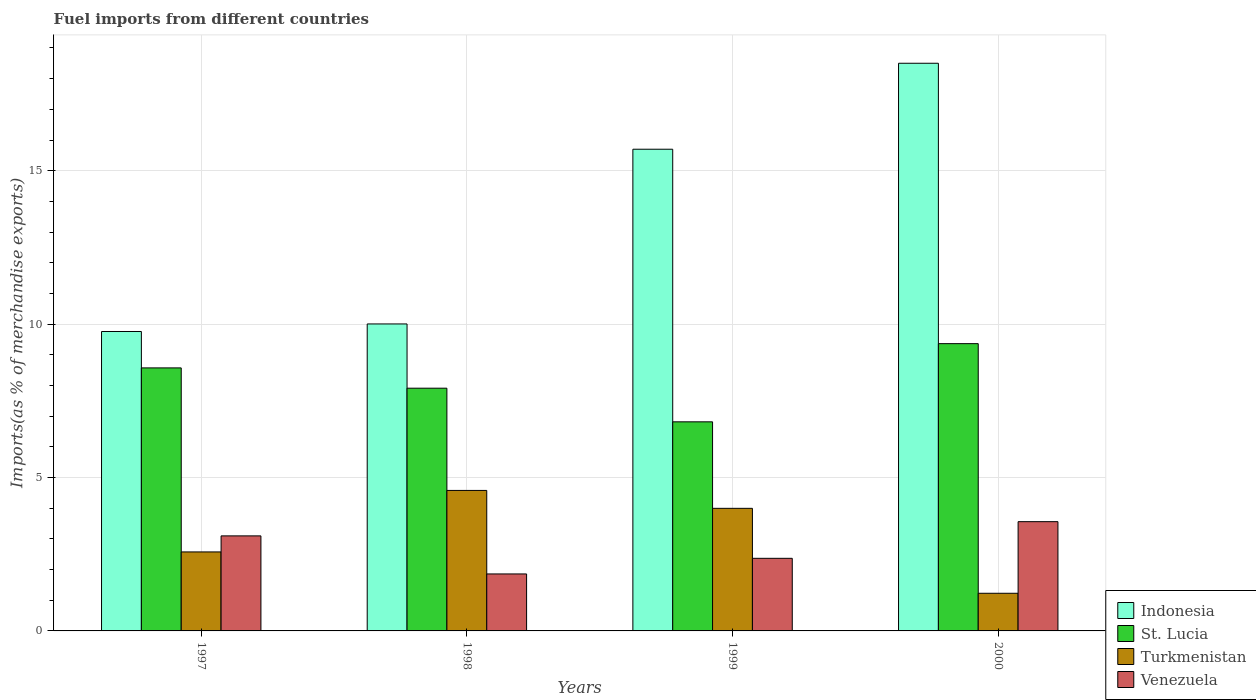How many different coloured bars are there?
Your response must be concise. 4. How many groups of bars are there?
Give a very brief answer. 4. Are the number of bars per tick equal to the number of legend labels?
Your response must be concise. Yes. How many bars are there on the 2nd tick from the left?
Provide a short and direct response. 4. What is the label of the 2nd group of bars from the left?
Offer a terse response. 1998. In how many cases, is the number of bars for a given year not equal to the number of legend labels?
Your answer should be very brief. 0. What is the percentage of imports to different countries in Turkmenistan in 2000?
Give a very brief answer. 1.23. Across all years, what is the maximum percentage of imports to different countries in St. Lucia?
Give a very brief answer. 9.36. Across all years, what is the minimum percentage of imports to different countries in Venezuela?
Make the answer very short. 1.86. In which year was the percentage of imports to different countries in St. Lucia minimum?
Give a very brief answer. 1999. What is the total percentage of imports to different countries in Indonesia in the graph?
Ensure brevity in your answer.  53.97. What is the difference between the percentage of imports to different countries in St. Lucia in 1998 and that in 1999?
Make the answer very short. 1.1. What is the difference between the percentage of imports to different countries in St. Lucia in 1998 and the percentage of imports to different countries in Venezuela in 1999?
Ensure brevity in your answer.  5.54. What is the average percentage of imports to different countries in St. Lucia per year?
Your answer should be very brief. 8.17. In the year 1998, what is the difference between the percentage of imports to different countries in Turkmenistan and percentage of imports to different countries in Venezuela?
Make the answer very short. 2.72. In how many years, is the percentage of imports to different countries in Indonesia greater than 8 %?
Make the answer very short. 4. What is the ratio of the percentage of imports to different countries in Venezuela in 1997 to that in 2000?
Make the answer very short. 0.87. What is the difference between the highest and the second highest percentage of imports to different countries in Indonesia?
Ensure brevity in your answer.  2.8. What is the difference between the highest and the lowest percentage of imports to different countries in Venezuela?
Make the answer very short. 1.7. In how many years, is the percentage of imports to different countries in Turkmenistan greater than the average percentage of imports to different countries in Turkmenistan taken over all years?
Ensure brevity in your answer.  2. Is it the case that in every year, the sum of the percentage of imports to different countries in St. Lucia and percentage of imports to different countries in Indonesia is greater than the sum of percentage of imports to different countries in Venezuela and percentage of imports to different countries in Turkmenistan?
Your response must be concise. Yes. What does the 4th bar from the left in 1998 represents?
Offer a terse response. Venezuela. What does the 2nd bar from the right in 2000 represents?
Give a very brief answer. Turkmenistan. Is it the case that in every year, the sum of the percentage of imports to different countries in Turkmenistan and percentage of imports to different countries in Indonesia is greater than the percentage of imports to different countries in St. Lucia?
Offer a terse response. Yes. How many bars are there?
Ensure brevity in your answer.  16. Are all the bars in the graph horizontal?
Provide a succinct answer. No. How many years are there in the graph?
Provide a short and direct response. 4. Does the graph contain any zero values?
Keep it short and to the point. No. Does the graph contain grids?
Your answer should be compact. Yes. Where does the legend appear in the graph?
Ensure brevity in your answer.  Bottom right. What is the title of the graph?
Offer a very short reply. Fuel imports from different countries. Does "Cayman Islands" appear as one of the legend labels in the graph?
Make the answer very short. No. What is the label or title of the Y-axis?
Provide a short and direct response. Imports(as % of merchandise exports). What is the Imports(as % of merchandise exports) of Indonesia in 1997?
Provide a short and direct response. 9.76. What is the Imports(as % of merchandise exports) of St. Lucia in 1997?
Your response must be concise. 8.57. What is the Imports(as % of merchandise exports) in Turkmenistan in 1997?
Provide a succinct answer. 2.57. What is the Imports(as % of merchandise exports) of Venezuela in 1997?
Your answer should be compact. 3.1. What is the Imports(as % of merchandise exports) in Indonesia in 1998?
Make the answer very short. 10. What is the Imports(as % of merchandise exports) of St. Lucia in 1998?
Offer a very short reply. 7.91. What is the Imports(as % of merchandise exports) in Turkmenistan in 1998?
Offer a terse response. 4.58. What is the Imports(as % of merchandise exports) in Venezuela in 1998?
Provide a succinct answer. 1.86. What is the Imports(as % of merchandise exports) of Indonesia in 1999?
Your answer should be very brief. 15.7. What is the Imports(as % of merchandise exports) of St. Lucia in 1999?
Provide a succinct answer. 6.81. What is the Imports(as % of merchandise exports) of Turkmenistan in 1999?
Ensure brevity in your answer.  4. What is the Imports(as % of merchandise exports) in Venezuela in 1999?
Give a very brief answer. 2.37. What is the Imports(as % of merchandise exports) in Indonesia in 2000?
Provide a succinct answer. 18.5. What is the Imports(as % of merchandise exports) in St. Lucia in 2000?
Make the answer very short. 9.36. What is the Imports(as % of merchandise exports) of Turkmenistan in 2000?
Ensure brevity in your answer.  1.23. What is the Imports(as % of merchandise exports) in Venezuela in 2000?
Give a very brief answer. 3.56. Across all years, what is the maximum Imports(as % of merchandise exports) in Indonesia?
Give a very brief answer. 18.5. Across all years, what is the maximum Imports(as % of merchandise exports) of St. Lucia?
Provide a succinct answer. 9.36. Across all years, what is the maximum Imports(as % of merchandise exports) in Turkmenistan?
Your answer should be very brief. 4.58. Across all years, what is the maximum Imports(as % of merchandise exports) of Venezuela?
Offer a very short reply. 3.56. Across all years, what is the minimum Imports(as % of merchandise exports) in Indonesia?
Keep it short and to the point. 9.76. Across all years, what is the minimum Imports(as % of merchandise exports) of St. Lucia?
Offer a terse response. 6.81. Across all years, what is the minimum Imports(as % of merchandise exports) of Turkmenistan?
Provide a succinct answer. 1.23. Across all years, what is the minimum Imports(as % of merchandise exports) in Venezuela?
Offer a very short reply. 1.86. What is the total Imports(as % of merchandise exports) in Indonesia in the graph?
Keep it short and to the point. 53.97. What is the total Imports(as % of merchandise exports) in St. Lucia in the graph?
Make the answer very short. 32.66. What is the total Imports(as % of merchandise exports) in Turkmenistan in the graph?
Offer a terse response. 12.38. What is the total Imports(as % of merchandise exports) of Venezuela in the graph?
Ensure brevity in your answer.  10.88. What is the difference between the Imports(as % of merchandise exports) in Indonesia in 1997 and that in 1998?
Give a very brief answer. -0.25. What is the difference between the Imports(as % of merchandise exports) of St. Lucia in 1997 and that in 1998?
Your answer should be compact. 0.66. What is the difference between the Imports(as % of merchandise exports) of Turkmenistan in 1997 and that in 1998?
Your answer should be compact. -2. What is the difference between the Imports(as % of merchandise exports) of Venezuela in 1997 and that in 1998?
Offer a terse response. 1.24. What is the difference between the Imports(as % of merchandise exports) of Indonesia in 1997 and that in 1999?
Provide a short and direct response. -5.94. What is the difference between the Imports(as % of merchandise exports) in St. Lucia in 1997 and that in 1999?
Give a very brief answer. 1.76. What is the difference between the Imports(as % of merchandise exports) in Turkmenistan in 1997 and that in 1999?
Provide a short and direct response. -1.42. What is the difference between the Imports(as % of merchandise exports) of Venezuela in 1997 and that in 1999?
Offer a very short reply. 0.73. What is the difference between the Imports(as % of merchandise exports) of Indonesia in 1997 and that in 2000?
Provide a succinct answer. -8.74. What is the difference between the Imports(as % of merchandise exports) of St. Lucia in 1997 and that in 2000?
Your answer should be very brief. -0.79. What is the difference between the Imports(as % of merchandise exports) of Turkmenistan in 1997 and that in 2000?
Make the answer very short. 1.35. What is the difference between the Imports(as % of merchandise exports) of Venezuela in 1997 and that in 2000?
Give a very brief answer. -0.46. What is the difference between the Imports(as % of merchandise exports) of Indonesia in 1998 and that in 1999?
Offer a terse response. -5.69. What is the difference between the Imports(as % of merchandise exports) of St. Lucia in 1998 and that in 1999?
Offer a very short reply. 1.1. What is the difference between the Imports(as % of merchandise exports) in Turkmenistan in 1998 and that in 1999?
Provide a succinct answer. 0.58. What is the difference between the Imports(as % of merchandise exports) in Venezuela in 1998 and that in 1999?
Offer a very short reply. -0.51. What is the difference between the Imports(as % of merchandise exports) in Indonesia in 1998 and that in 2000?
Ensure brevity in your answer.  -8.5. What is the difference between the Imports(as % of merchandise exports) in St. Lucia in 1998 and that in 2000?
Ensure brevity in your answer.  -1.45. What is the difference between the Imports(as % of merchandise exports) in Turkmenistan in 1998 and that in 2000?
Make the answer very short. 3.35. What is the difference between the Imports(as % of merchandise exports) in Venezuela in 1998 and that in 2000?
Your answer should be compact. -1.7. What is the difference between the Imports(as % of merchandise exports) in Indonesia in 1999 and that in 2000?
Give a very brief answer. -2.8. What is the difference between the Imports(as % of merchandise exports) in St. Lucia in 1999 and that in 2000?
Make the answer very short. -2.55. What is the difference between the Imports(as % of merchandise exports) of Turkmenistan in 1999 and that in 2000?
Provide a succinct answer. 2.77. What is the difference between the Imports(as % of merchandise exports) of Venezuela in 1999 and that in 2000?
Your answer should be compact. -1.19. What is the difference between the Imports(as % of merchandise exports) of Indonesia in 1997 and the Imports(as % of merchandise exports) of St. Lucia in 1998?
Provide a succinct answer. 1.85. What is the difference between the Imports(as % of merchandise exports) in Indonesia in 1997 and the Imports(as % of merchandise exports) in Turkmenistan in 1998?
Make the answer very short. 5.18. What is the difference between the Imports(as % of merchandise exports) in Indonesia in 1997 and the Imports(as % of merchandise exports) in Venezuela in 1998?
Keep it short and to the point. 7.9. What is the difference between the Imports(as % of merchandise exports) in St. Lucia in 1997 and the Imports(as % of merchandise exports) in Turkmenistan in 1998?
Offer a very short reply. 3.99. What is the difference between the Imports(as % of merchandise exports) in St. Lucia in 1997 and the Imports(as % of merchandise exports) in Venezuela in 1998?
Keep it short and to the point. 6.72. What is the difference between the Imports(as % of merchandise exports) in Turkmenistan in 1997 and the Imports(as % of merchandise exports) in Venezuela in 1998?
Your answer should be compact. 0.72. What is the difference between the Imports(as % of merchandise exports) of Indonesia in 1997 and the Imports(as % of merchandise exports) of St. Lucia in 1999?
Offer a very short reply. 2.94. What is the difference between the Imports(as % of merchandise exports) of Indonesia in 1997 and the Imports(as % of merchandise exports) of Turkmenistan in 1999?
Keep it short and to the point. 5.76. What is the difference between the Imports(as % of merchandise exports) in Indonesia in 1997 and the Imports(as % of merchandise exports) in Venezuela in 1999?
Keep it short and to the point. 7.39. What is the difference between the Imports(as % of merchandise exports) of St. Lucia in 1997 and the Imports(as % of merchandise exports) of Turkmenistan in 1999?
Make the answer very short. 4.58. What is the difference between the Imports(as % of merchandise exports) in St. Lucia in 1997 and the Imports(as % of merchandise exports) in Venezuela in 1999?
Give a very brief answer. 6.21. What is the difference between the Imports(as % of merchandise exports) in Turkmenistan in 1997 and the Imports(as % of merchandise exports) in Venezuela in 1999?
Your answer should be very brief. 0.21. What is the difference between the Imports(as % of merchandise exports) of Indonesia in 1997 and the Imports(as % of merchandise exports) of St. Lucia in 2000?
Provide a succinct answer. 0.4. What is the difference between the Imports(as % of merchandise exports) in Indonesia in 1997 and the Imports(as % of merchandise exports) in Turkmenistan in 2000?
Your answer should be compact. 8.53. What is the difference between the Imports(as % of merchandise exports) in Indonesia in 1997 and the Imports(as % of merchandise exports) in Venezuela in 2000?
Your response must be concise. 6.2. What is the difference between the Imports(as % of merchandise exports) in St. Lucia in 1997 and the Imports(as % of merchandise exports) in Turkmenistan in 2000?
Provide a succinct answer. 7.35. What is the difference between the Imports(as % of merchandise exports) in St. Lucia in 1997 and the Imports(as % of merchandise exports) in Venezuela in 2000?
Make the answer very short. 5.01. What is the difference between the Imports(as % of merchandise exports) in Turkmenistan in 1997 and the Imports(as % of merchandise exports) in Venezuela in 2000?
Offer a very short reply. -0.99. What is the difference between the Imports(as % of merchandise exports) of Indonesia in 1998 and the Imports(as % of merchandise exports) of St. Lucia in 1999?
Your response must be concise. 3.19. What is the difference between the Imports(as % of merchandise exports) of Indonesia in 1998 and the Imports(as % of merchandise exports) of Turkmenistan in 1999?
Make the answer very short. 6.01. What is the difference between the Imports(as % of merchandise exports) in Indonesia in 1998 and the Imports(as % of merchandise exports) in Venezuela in 1999?
Ensure brevity in your answer.  7.64. What is the difference between the Imports(as % of merchandise exports) of St. Lucia in 1998 and the Imports(as % of merchandise exports) of Turkmenistan in 1999?
Offer a very short reply. 3.92. What is the difference between the Imports(as % of merchandise exports) of St. Lucia in 1998 and the Imports(as % of merchandise exports) of Venezuela in 1999?
Offer a very short reply. 5.54. What is the difference between the Imports(as % of merchandise exports) in Turkmenistan in 1998 and the Imports(as % of merchandise exports) in Venezuela in 1999?
Provide a short and direct response. 2.21. What is the difference between the Imports(as % of merchandise exports) in Indonesia in 1998 and the Imports(as % of merchandise exports) in St. Lucia in 2000?
Give a very brief answer. 0.64. What is the difference between the Imports(as % of merchandise exports) of Indonesia in 1998 and the Imports(as % of merchandise exports) of Turkmenistan in 2000?
Your answer should be compact. 8.78. What is the difference between the Imports(as % of merchandise exports) in Indonesia in 1998 and the Imports(as % of merchandise exports) in Venezuela in 2000?
Provide a succinct answer. 6.44. What is the difference between the Imports(as % of merchandise exports) in St. Lucia in 1998 and the Imports(as % of merchandise exports) in Turkmenistan in 2000?
Provide a succinct answer. 6.68. What is the difference between the Imports(as % of merchandise exports) in St. Lucia in 1998 and the Imports(as % of merchandise exports) in Venezuela in 2000?
Give a very brief answer. 4.35. What is the difference between the Imports(as % of merchandise exports) in Turkmenistan in 1998 and the Imports(as % of merchandise exports) in Venezuela in 2000?
Your answer should be very brief. 1.02. What is the difference between the Imports(as % of merchandise exports) of Indonesia in 1999 and the Imports(as % of merchandise exports) of St. Lucia in 2000?
Your answer should be compact. 6.34. What is the difference between the Imports(as % of merchandise exports) of Indonesia in 1999 and the Imports(as % of merchandise exports) of Turkmenistan in 2000?
Make the answer very short. 14.47. What is the difference between the Imports(as % of merchandise exports) in Indonesia in 1999 and the Imports(as % of merchandise exports) in Venezuela in 2000?
Your answer should be compact. 12.14. What is the difference between the Imports(as % of merchandise exports) of St. Lucia in 1999 and the Imports(as % of merchandise exports) of Turkmenistan in 2000?
Make the answer very short. 5.59. What is the difference between the Imports(as % of merchandise exports) of St. Lucia in 1999 and the Imports(as % of merchandise exports) of Venezuela in 2000?
Ensure brevity in your answer.  3.25. What is the difference between the Imports(as % of merchandise exports) of Turkmenistan in 1999 and the Imports(as % of merchandise exports) of Venezuela in 2000?
Ensure brevity in your answer.  0.43. What is the average Imports(as % of merchandise exports) in Indonesia per year?
Offer a terse response. 13.49. What is the average Imports(as % of merchandise exports) of St. Lucia per year?
Offer a terse response. 8.17. What is the average Imports(as % of merchandise exports) of Turkmenistan per year?
Your response must be concise. 3.09. What is the average Imports(as % of merchandise exports) of Venezuela per year?
Offer a terse response. 2.72. In the year 1997, what is the difference between the Imports(as % of merchandise exports) of Indonesia and Imports(as % of merchandise exports) of St. Lucia?
Provide a succinct answer. 1.19. In the year 1997, what is the difference between the Imports(as % of merchandise exports) of Indonesia and Imports(as % of merchandise exports) of Turkmenistan?
Provide a succinct answer. 7.18. In the year 1997, what is the difference between the Imports(as % of merchandise exports) in Indonesia and Imports(as % of merchandise exports) in Venezuela?
Provide a short and direct response. 6.66. In the year 1997, what is the difference between the Imports(as % of merchandise exports) of St. Lucia and Imports(as % of merchandise exports) of Turkmenistan?
Your answer should be compact. 6. In the year 1997, what is the difference between the Imports(as % of merchandise exports) of St. Lucia and Imports(as % of merchandise exports) of Venezuela?
Ensure brevity in your answer.  5.48. In the year 1997, what is the difference between the Imports(as % of merchandise exports) of Turkmenistan and Imports(as % of merchandise exports) of Venezuela?
Keep it short and to the point. -0.52. In the year 1998, what is the difference between the Imports(as % of merchandise exports) in Indonesia and Imports(as % of merchandise exports) in St. Lucia?
Provide a succinct answer. 2.09. In the year 1998, what is the difference between the Imports(as % of merchandise exports) in Indonesia and Imports(as % of merchandise exports) in Turkmenistan?
Your answer should be compact. 5.43. In the year 1998, what is the difference between the Imports(as % of merchandise exports) of Indonesia and Imports(as % of merchandise exports) of Venezuela?
Ensure brevity in your answer.  8.15. In the year 1998, what is the difference between the Imports(as % of merchandise exports) in St. Lucia and Imports(as % of merchandise exports) in Turkmenistan?
Your answer should be very brief. 3.33. In the year 1998, what is the difference between the Imports(as % of merchandise exports) of St. Lucia and Imports(as % of merchandise exports) of Venezuela?
Your answer should be very brief. 6.05. In the year 1998, what is the difference between the Imports(as % of merchandise exports) of Turkmenistan and Imports(as % of merchandise exports) of Venezuela?
Keep it short and to the point. 2.72. In the year 1999, what is the difference between the Imports(as % of merchandise exports) of Indonesia and Imports(as % of merchandise exports) of St. Lucia?
Provide a succinct answer. 8.88. In the year 1999, what is the difference between the Imports(as % of merchandise exports) in Indonesia and Imports(as % of merchandise exports) in Turkmenistan?
Make the answer very short. 11.7. In the year 1999, what is the difference between the Imports(as % of merchandise exports) in Indonesia and Imports(as % of merchandise exports) in Venezuela?
Your answer should be very brief. 13.33. In the year 1999, what is the difference between the Imports(as % of merchandise exports) in St. Lucia and Imports(as % of merchandise exports) in Turkmenistan?
Offer a very short reply. 2.82. In the year 1999, what is the difference between the Imports(as % of merchandise exports) in St. Lucia and Imports(as % of merchandise exports) in Venezuela?
Provide a succinct answer. 4.45. In the year 1999, what is the difference between the Imports(as % of merchandise exports) in Turkmenistan and Imports(as % of merchandise exports) in Venezuela?
Your answer should be very brief. 1.63. In the year 2000, what is the difference between the Imports(as % of merchandise exports) of Indonesia and Imports(as % of merchandise exports) of St. Lucia?
Provide a succinct answer. 9.14. In the year 2000, what is the difference between the Imports(as % of merchandise exports) of Indonesia and Imports(as % of merchandise exports) of Turkmenistan?
Keep it short and to the point. 17.27. In the year 2000, what is the difference between the Imports(as % of merchandise exports) of Indonesia and Imports(as % of merchandise exports) of Venezuela?
Provide a succinct answer. 14.94. In the year 2000, what is the difference between the Imports(as % of merchandise exports) of St. Lucia and Imports(as % of merchandise exports) of Turkmenistan?
Provide a short and direct response. 8.14. In the year 2000, what is the difference between the Imports(as % of merchandise exports) of St. Lucia and Imports(as % of merchandise exports) of Venezuela?
Your answer should be very brief. 5.8. In the year 2000, what is the difference between the Imports(as % of merchandise exports) of Turkmenistan and Imports(as % of merchandise exports) of Venezuela?
Offer a very short reply. -2.33. What is the ratio of the Imports(as % of merchandise exports) in Indonesia in 1997 to that in 1998?
Make the answer very short. 0.98. What is the ratio of the Imports(as % of merchandise exports) in St. Lucia in 1997 to that in 1998?
Offer a very short reply. 1.08. What is the ratio of the Imports(as % of merchandise exports) of Turkmenistan in 1997 to that in 1998?
Your response must be concise. 0.56. What is the ratio of the Imports(as % of merchandise exports) of Venezuela in 1997 to that in 1998?
Make the answer very short. 1.67. What is the ratio of the Imports(as % of merchandise exports) of Indonesia in 1997 to that in 1999?
Keep it short and to the point. 0.62. What is the ratio of the Imports(as % of merchandise exports) of St. Lucia in 1997 to that in 1999?
Provide a short and direct response. 1.26. What is the ratio of the Imports(as % of merchandise exports) in Turkmenistan in 1997 to that in 1999?
Offer a very short reply. 0.64. What is the ratio of the Imports(as % of merchandise exports) of Venezuela in 1997 to that in 1999?
Provide a short and direct response. 1.31. What is the ratio of the Imports(as % of merchandise exports) of Indonesia in 1997 to that in 2000?
Ensure brevity in your answer.  0.53. What is the ratio of the Imports(as % of merchandise exports) of St. Lucia in 1997 to that in 2000?
Provide a short and direct response. 0.92. What is the ratio of the Imports(as % of merchandise exports) of Turkmenistan in 1997 to that in 2000?
Ensure brevity in your answer.  2.1. What is the ratio of the Imports(as % of merchandise exports) of Venezuela in 1997 to that in 2000?
Give a very brief answer. 0.87. What is the ratio of the Imports(as % of merchandise exports) of Indonesia in 1998 to that in 1999?
Make the answer very short. 0.64. What is the ratio of the Imports(as % of merchandise exports) in St. Lucia in 1998 to that in 1999?
Keep it short and to the point. 1.16. What is the ratio of the Imports(as % of merchandise exports) of Turkmenistan in 1998 to that in 1999?
Your response must be concise. 1.15. What is the ratio of the Imports(as % of merchandise exports) of Venezuela in 1998 to that in 1999?
Your answer should be very brief. 0.78. What is the ratio of the Imports(as % of merchandise exports) in Indonesia in 1998 to that in 2000?
Your answer should be very brief. 0.54. What is the ratio of the Imports(as % of merchandise exports) in St. Lucia in 1998 to that in 2000?
Offer a terse response. 0.84. What is the ratio of the Imports(as % of merchandise exports) in Turkmenistan in 1998 to that in 2000?
Your answer should be compact. 3.73. What is the ratio of the Imports(as % of merchandise exports) in Venezuela in 1998 to that in 2000?
Provide a short and direct response. 0.52. What is the ratio of the Imports(as % of merchandise exports) in Indonesia in 1999 to that in 2000?
Offer a very short reply. 0.85. What is the ratio of the Imports(as % of merchandise exports) in St. Lucia in 1999 to that in 2000?
Your response must be concise. 0.73. What is the ratio of the Imports(as % of merchandise exports) of Turkmenistan in 1999 to that in 2000?
Ensure brevity in your answer.  3.26. What is the ratio of the Imports(as % of merchandise exports) of Venezuela in 1999 to that in 2000?
Provide a short and direct response. 0.66. What is the difference between the highest and the second highest Imports(as % of merchandise exports) in Indonesia?
Keep it short and to the point. 2.8. What is the difference between the highest and the second highest Imports(as % of merchandise exports) of St. Lucia?
Ensure brevity in your answer.  0.79. What is the difference between the highest and the second highest Imports(as % of merchandise exports) of Turkmenistan?
Give a very brief answer. 0.58. What is the difference between the highest and the second highest Imports(as % of merchandise exports) in Venezuela?
Ensure brevity in your answer.  0.46. What is the difference between the highest and the lowest Imports(as % of merchandise exports) of Indonesia?
Make the answer very short. 8.74. What is the difference between the highest and the lowest Imports(as % of merchandise exports) of St. Lucia?
Your response must be concise. 2.55. What is the difference between the highest and the lowest Imports(as % of merchandise exports) of Turkmenistan?
Make the answer very short. 3.35. What is the difference between the highest and the lowest Imports(as % of merchandise exports) of Venezuela?
Offer a terse response. 1.7. 